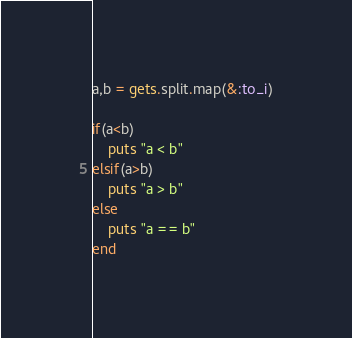Convert code to text. <code><loc_0><loc_0><loc_500><loc_500><_Ruby_>a,b = gets.split.map(&:to_i)

if(a<b)
    puts "a < b"
elsif(a>b)
    puts "a > b"
else
    puts "a == b"
end</code> 